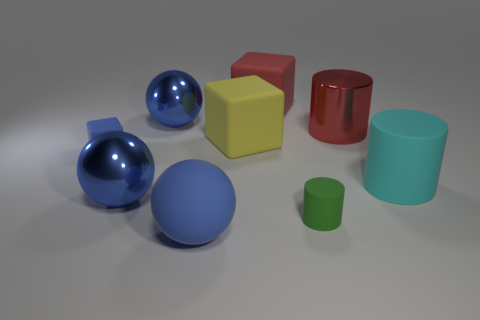How many blue balls must be subtracted to get 1 blue balls? 2 Subtract 1 cubes. How many cubes are left? 2 Add 1 tiny cyan metallic blocks. How many objects exist? 10 Subtract all spheres. How many objects are left? 6 Add 9 big gray metallic cubes. How many big gray metallic cubes exist? 9 Subtract 0 brown cylinders. How many objects are left? 9 Subtract all small cyan metal cylinders. Subtract all large blue metal things. How many objects are left? 7 Add 3 large yellow matte objects. How many large yellow matte objects are left? 4 